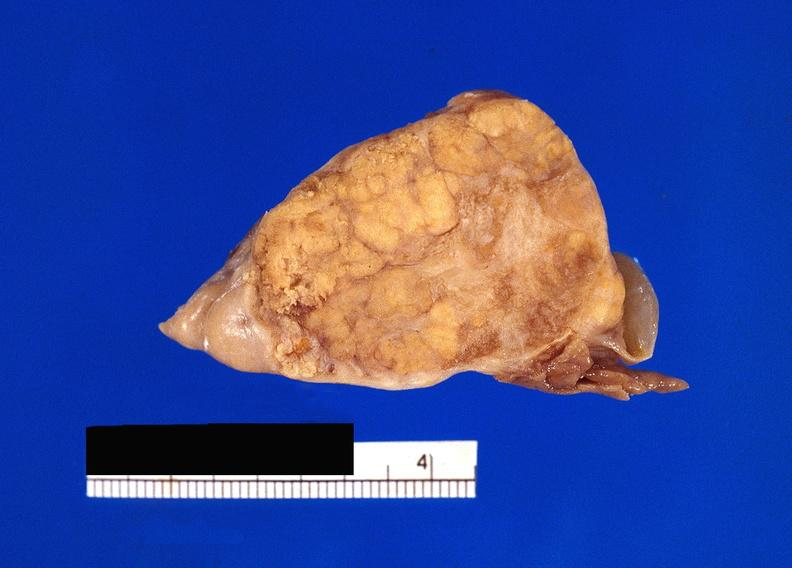what does this image show?
Answer the question using a single word or phrase. Pancreatic fat necrosis 